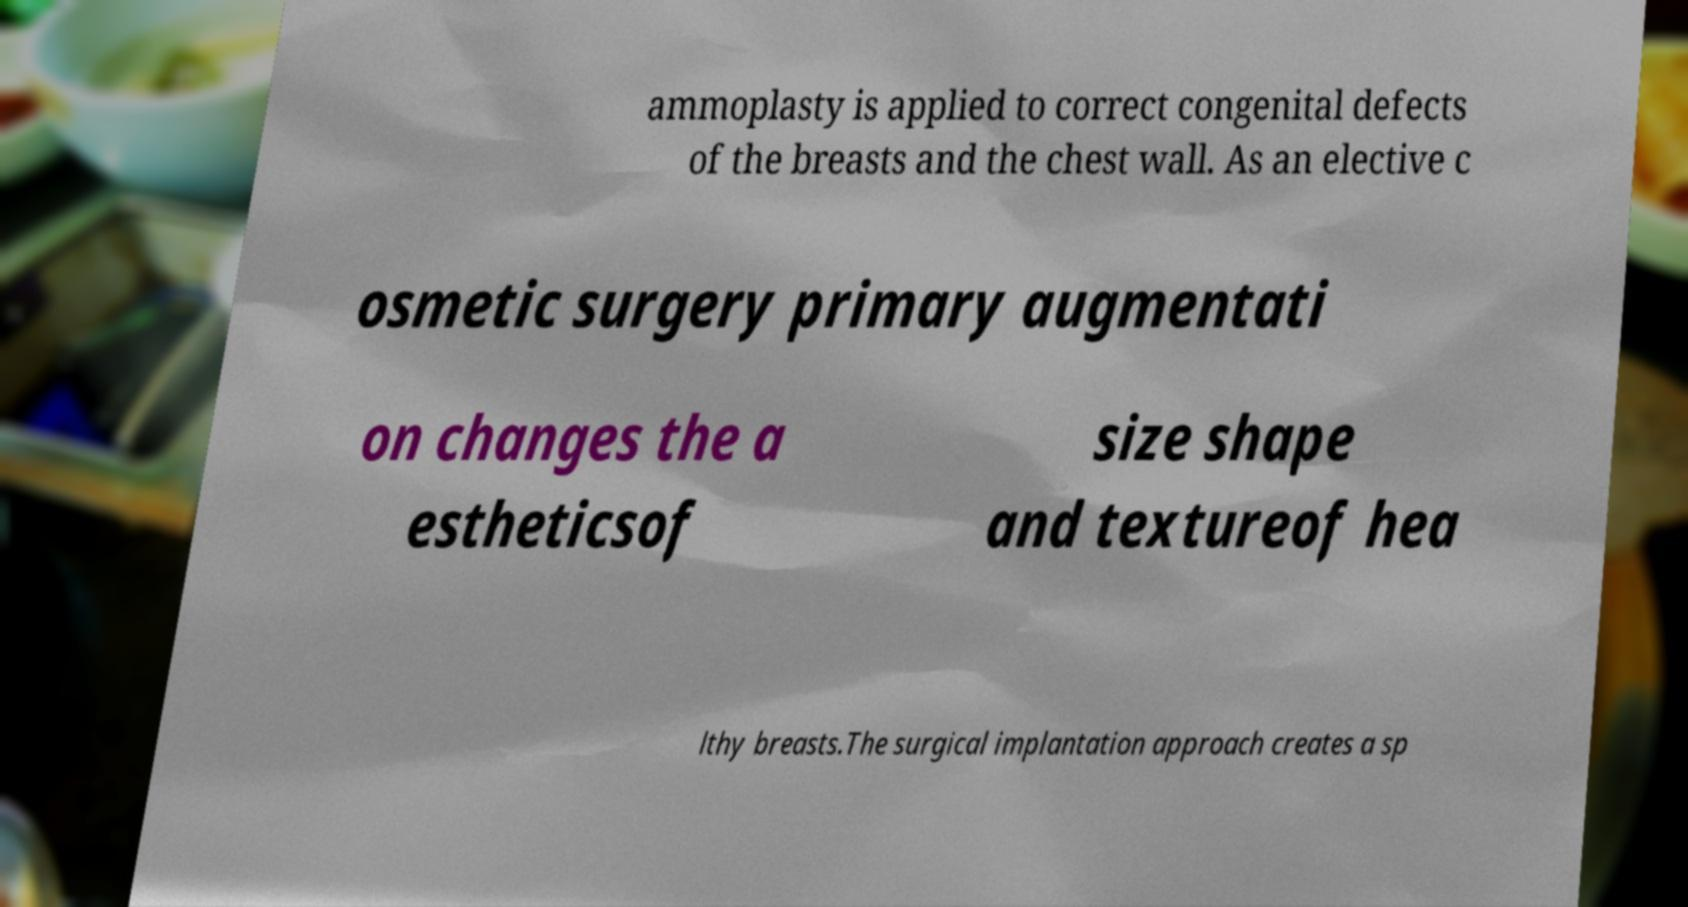There's text embedded in this image that I need extracted. Can you transcribe it verbatim? ammoplasty is applied to correct congenital defects of the breasts and the chest wall. As an elective c osmetic surgery primary augmentati on changes the a estheticsof size shape and textureof hea lthy breasts.The surgical implantation approach creates a sp 